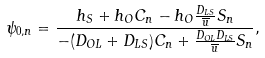Convert formula to latex. <formula><loc_0><loc_0><loc_500><loc_500>\psi _ { 0 , n } = \frac { h _ { S } + h _ { O } C _ { n } - h _ { O } \frac { D _ { L S } } { \overline { u } } S _ { n } } { - ( D _ { O L } + D _ { L S } ) C _ { n } + \frac { D _ { O L } D _ { L S } } { \overline { u } } S _ { n } } ,</formula> 